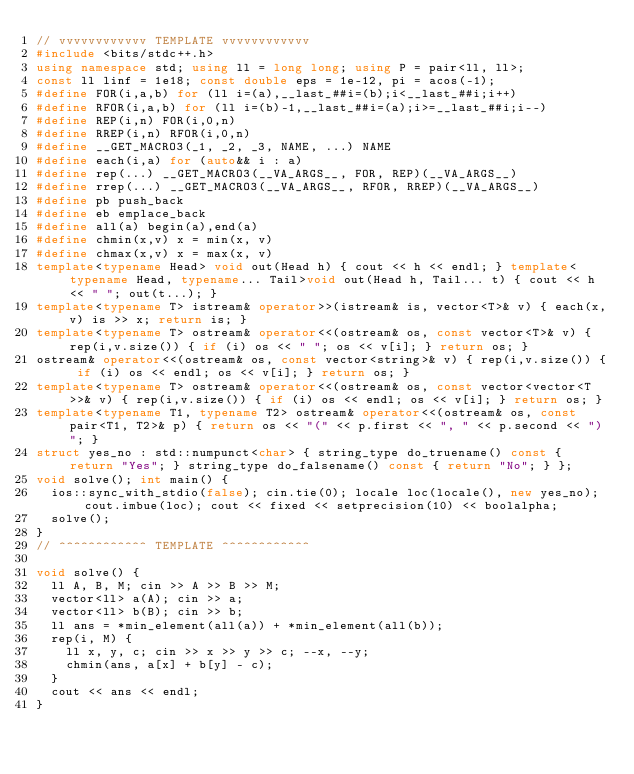<code> <loc_0><loc_0><loc_500><loc_500><_C++_>// vvvvvvvvvvvv TEMPLATE vvvvvvvvvvvv
#include <bits/stdc++.h>
using namespace std; using ll = long long; using P = pair<ll, ll>;
const ll linf = 1e18; const double eps = 1e-12, pi = acos(-1);
#define FOR(i,a,b) for (ll i=(a),__last_##i=(b);i<__last_##i;i++)
#define RFOR(i,a,b) for (ll i=(b)-1,__last_##i=(a);i>=__last_##i;i--)
#define REP(i,n) FOR(i,0,n)
#define RREP(i,n) RFOR(i,0,n)
#define __GET_MACRO3(_1, _2, _3, NAME, ...) NAME
#define each(i,a) for (auto&& i : a)
#define rep(...) __GET_MACRO3(__VA_ARGS__, FOR, REP)(__VA_ARGS__)
#define rrep(...) __GET_MACRO3(__VA_ARGS__, RFOR, RREP)(__VA_ARGS__)
#define pb push_back
#define eb emplace_back
#define all(a) begin(a),end(a)
#define chmin(x,v) x = min(x, v)
#define chmax(x,v) x = max(x, v)
template<typename Head> void out(Head h) { cout << h << endl; } template<typename Head, typename... Tail>void out(Head h, Tail... t) { cout << h << " "; out(t...); }
template<typename T> istream& operator>>(istream& is, vector<T>& v) { each(x,v) is >> x; return is; }
template<typename T> ostream& operator<<(ostream& os, const vector<T>& v) { rep(i,v.size()) { if (i) os << " "; os << v[i]; } return os; }
ostream& operator<<(ostream& os, const vector<string>& v) { rep(i,v.size()) { if (i) os << endl; os << v[i]; } return os; }
template<typename T> ostream& operator<<(ostream& os, const vector<vector<T>>& v) { rep(i,v.size()) { if (i) os << endl; os << v[i]; } return os; }
template<typename T1, typename T2> ostream& operator<<(ostream& os, const pair<T1, T2>& p) { return os << "(" << p.first << ", " << p.second << ")"; }
struct yes_no : std::numpunct<char> { string_type do_truename() const { return "Yes"; } string_type do_falsename() const { return "No"; } };
void solve(); int main() {
  ios::sync_with_stdio(false); cin.tie(0); locale loc(locale(), new yes_no); cout.imbue(loc); cout << fixed << setprecision(10) << boolalpha;
  solve();
}
// ^^^^^^^^^^^^ TEMPLATE ^^^^^^^^^^^^

void solve() {
  ll A, B, M; cin >> A >> B >> M;
  vector<ll> a(A); cin >> a;
  vector<ll> b(B); cin >> b;
  ll ans = *min_element(all(a)) + *min_element(all(b));
  rep(i, M) {
    ll x, y, c; cin >> x >> y >> c; --x, --y;
    chmin(ans, a[x] + b[y] - c);
  }
  cout << ans << endl;
}
</code> 